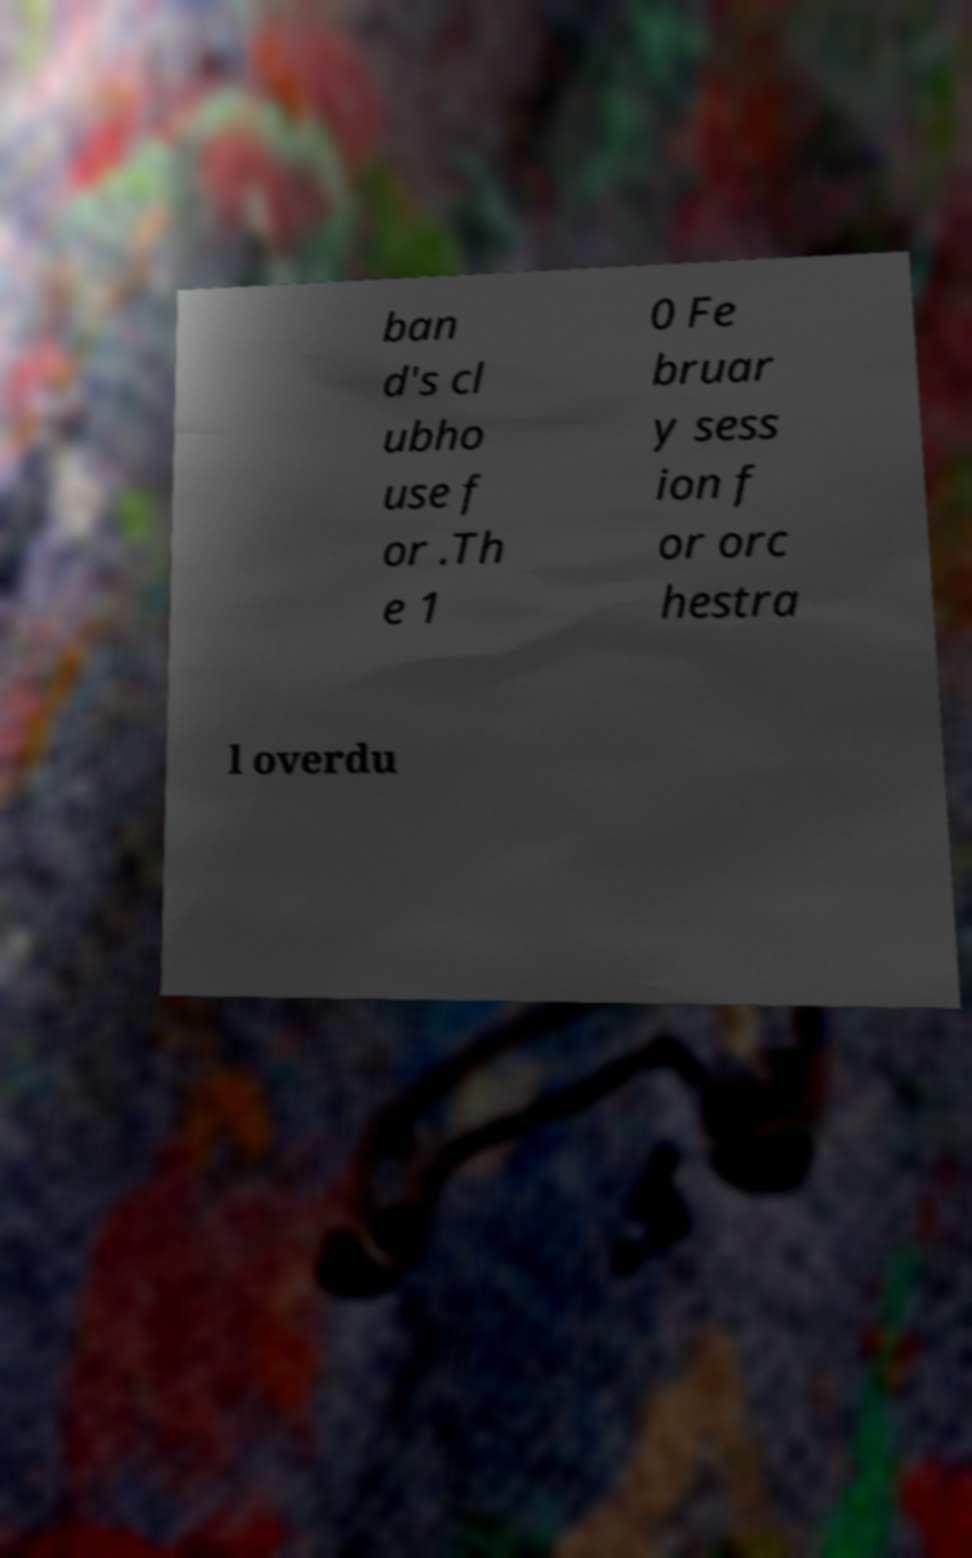What messages or text are displayed in this image? I need them in a readable, typed format. ban d's cl ubho use f or .Th e 1 0 Fe bruar y sess ion f or orc hestra l overdu 